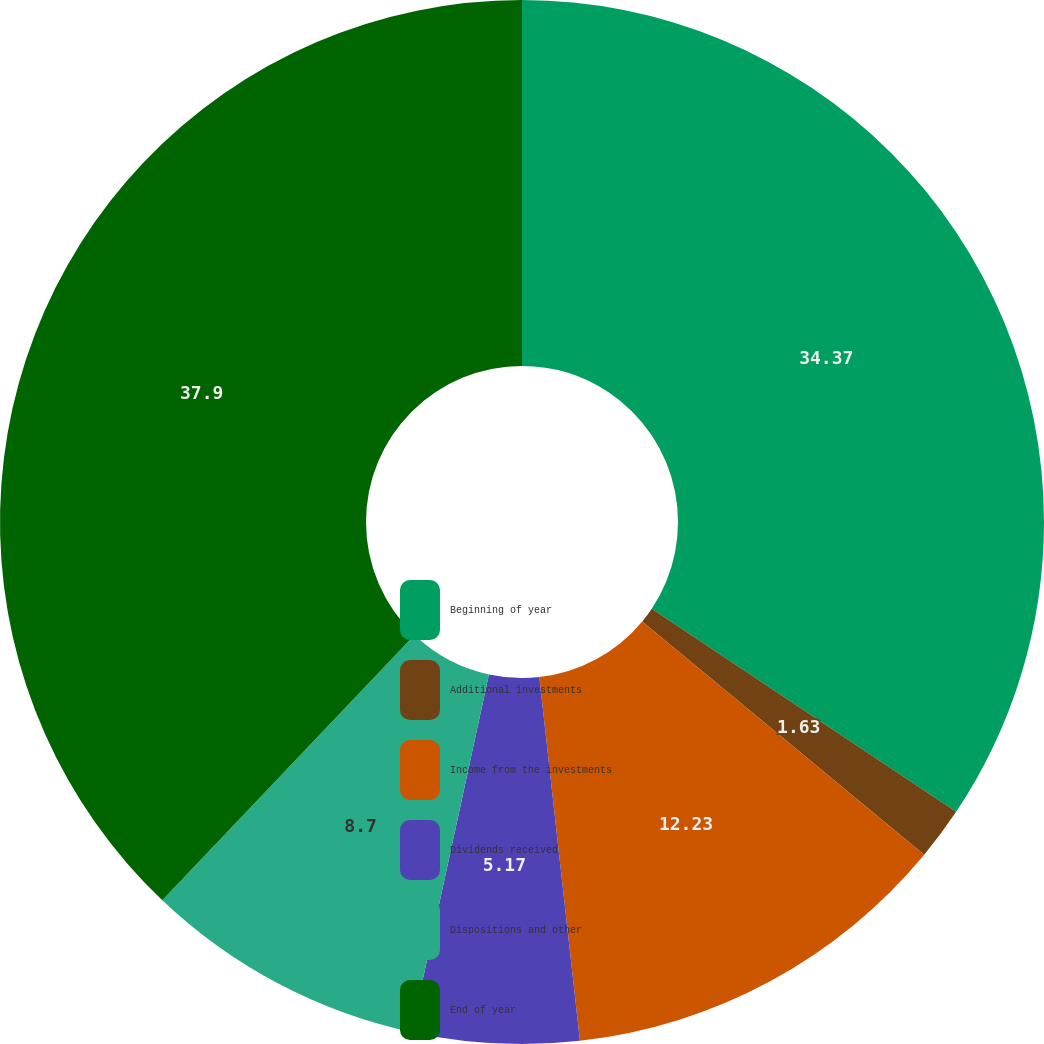<chart> <loc_0><loc_0><loc_500><loc_500><pie_chart><fcel>Beginning of year<fcel>Additional investments<fcel>Income from the investments<fcel>Dividends received<fcel>Dispositions and other<fcel>End of year<nl><fcel>34.37%<fcel>1.63%<fcel>12.23%<fcel>5.17%<fcel>8.7%<fcel>37.9%<nl></chart> 